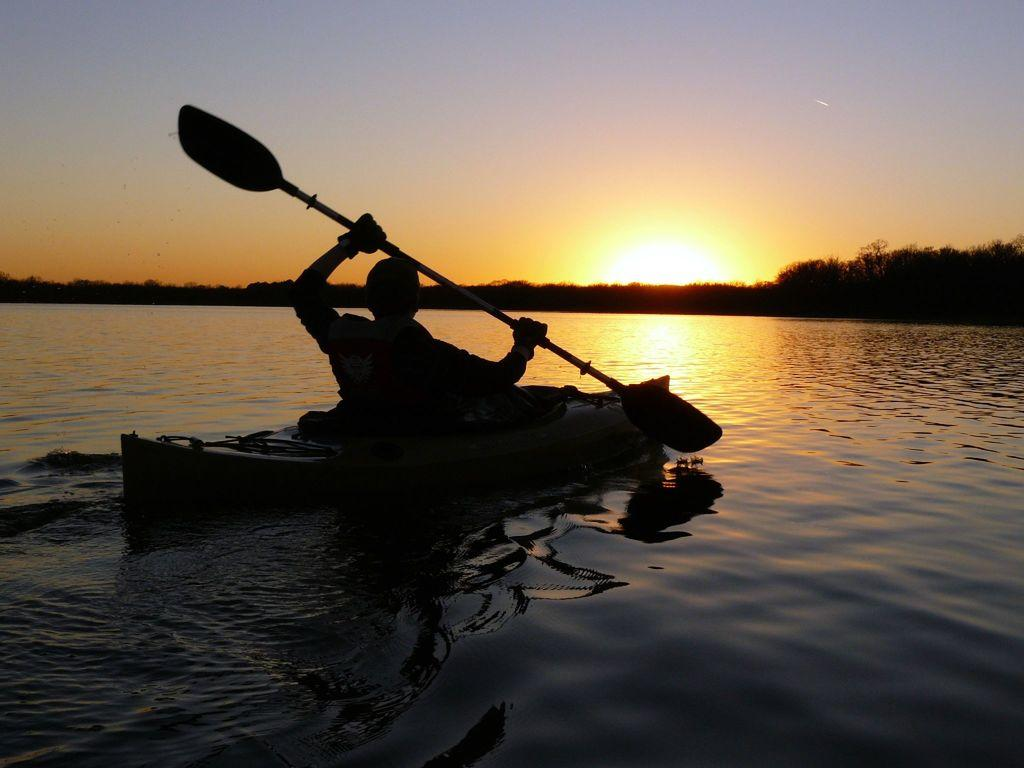Who is present in the image? There is a person in the image. What is the person doing in the image? The person is riding a boat. Where is the boat located? The boat is on a river. What can be seen in the background of the image? There are trees and the sky visible in the background of the image. What grade does the person receive for their performance in the image? There is no indication of a performance or grading system in the image, as it simply shows a person riding a boat on a river. 